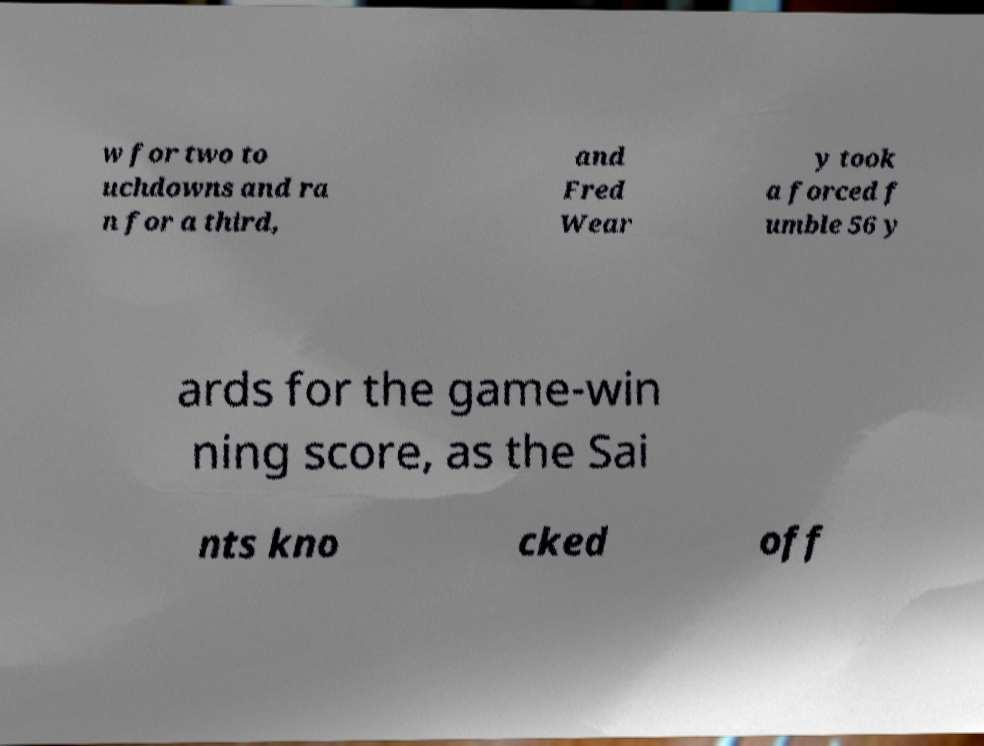What messages or text are displayed in this image? I need them in a readable, typed format. w for two to uchdowns and ra n for a third, and Fred Wear y took a forced f umble 56 y ards for the game-win ning score, as the Sai nts kno cked off 